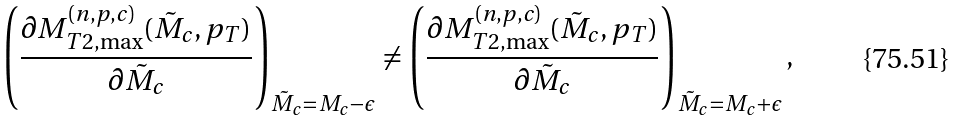<formula> <loc_0><loc_0><loc_500><loc_500>\left ( \frac { \partial M _ { T 2 , \max } ^ { ( n , p , c ) } ( \tilde { M } _ { c } , p _ { T } ) } { \partial \tilde { M } _ { c } } \right ) _ { \tilde { M } _ { c } = M _ { c } - \epsilon } \ne \left ( \frac { \partial M _ { T 2 , \max } ^ { ( n , p , c ) } ( \tilde { M } _ { c } , p _ { T } ) } { \partial \tilde { M } _ { c } } \right ) _ { \tilde { M } _ { c } = M _ { c } + \epsilon } ,</formula> 